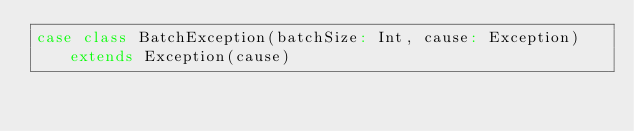Convert code to text. <code><loc_0><loc_0><loc_500><loc_500><_Scala_>case class BatchException(batchSize: Int, cause: Exception) extends Exception(cause)
</code> 